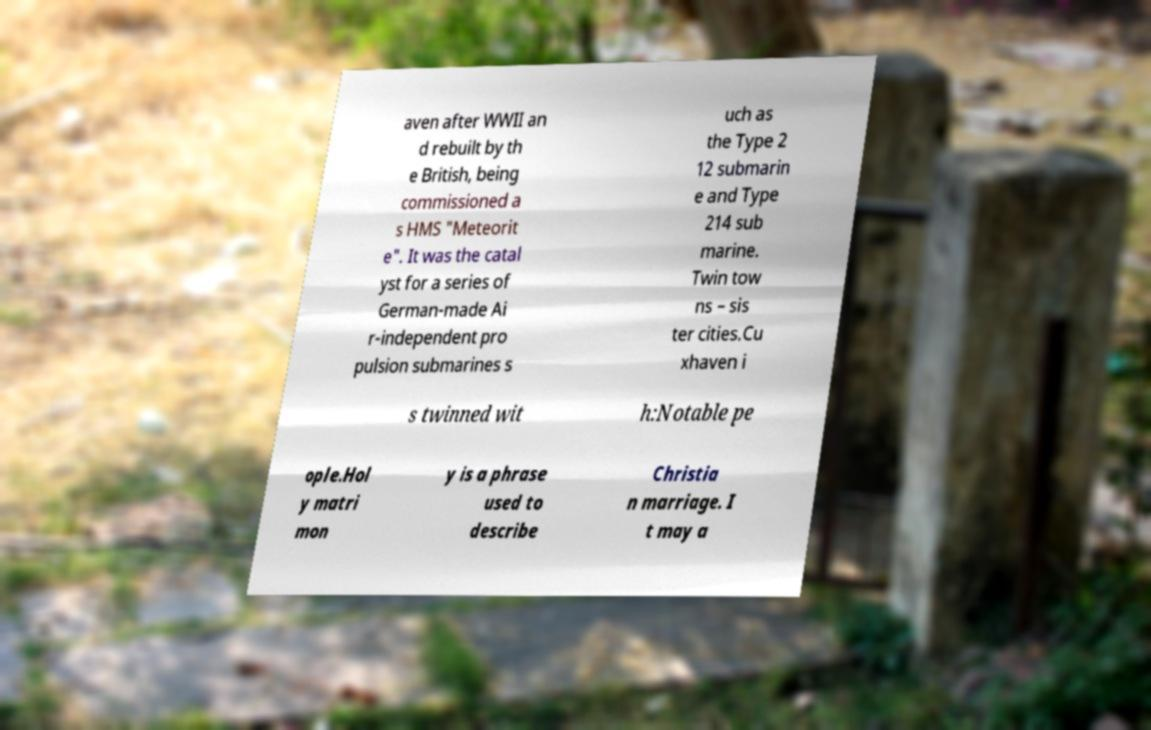Please identify and transcribe the text found in this image. aven after WWII an d rebuilt by th e British, being commissioned a s HMS "Meteorit e". It was the catal yst for a series of German-made Ai r-independent pro pulsion submarines s uch as the Type 2 12 submarin e and Type 214 sub marine. Twin tow ns – sis ter cities.Cu xhaven i s twinned wit h:Notable pe ople.Hol y matri mon y is a phrase used to describe Christia n marriage. I t may a 